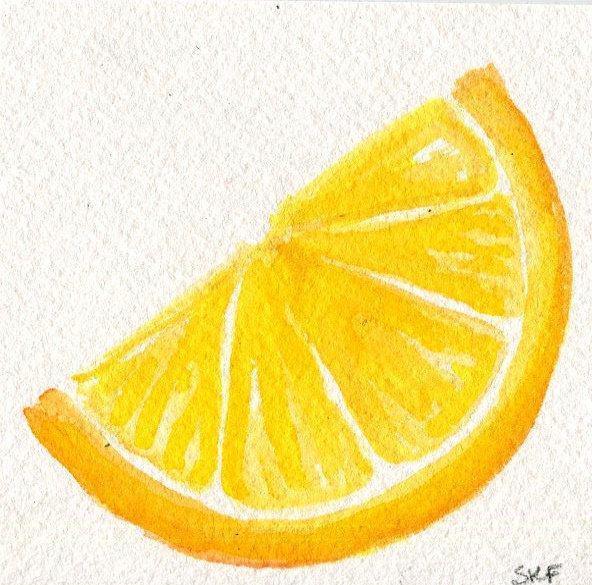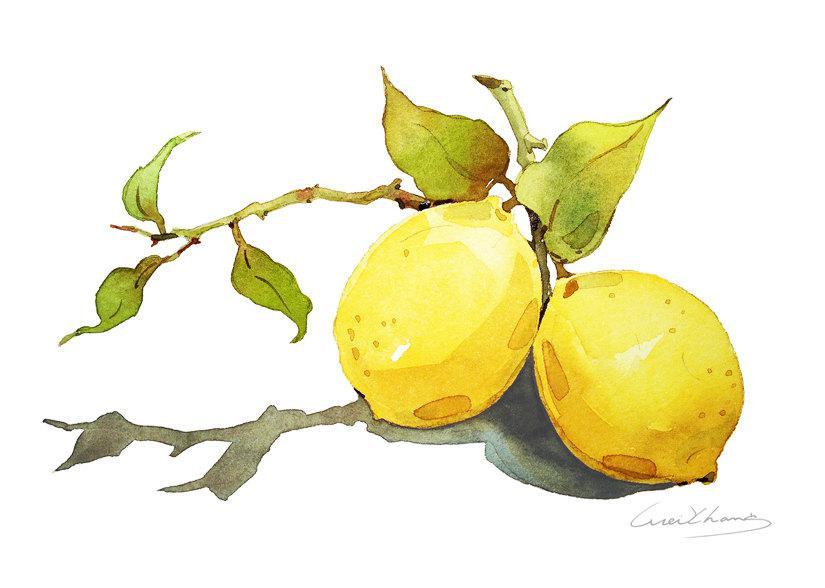The first image is the image on the left, the second image is the image on the right. Evaluate the accuracy of this statement regarding the images: "A stem and leaves are attached to a single lemon, while in a second image a lemon segment is beside one or more whole lemons.". Is it true? Answer yes or no. No. The first image is the image on the left, the second image is the image on the right. For the images shown, is this caption "Each image includes a whole yellow fruit and a green leaf, one image includes a half-section of fruit, and no image shows unpicked fruit growing on a branch." true? Answer yes or no. No. 